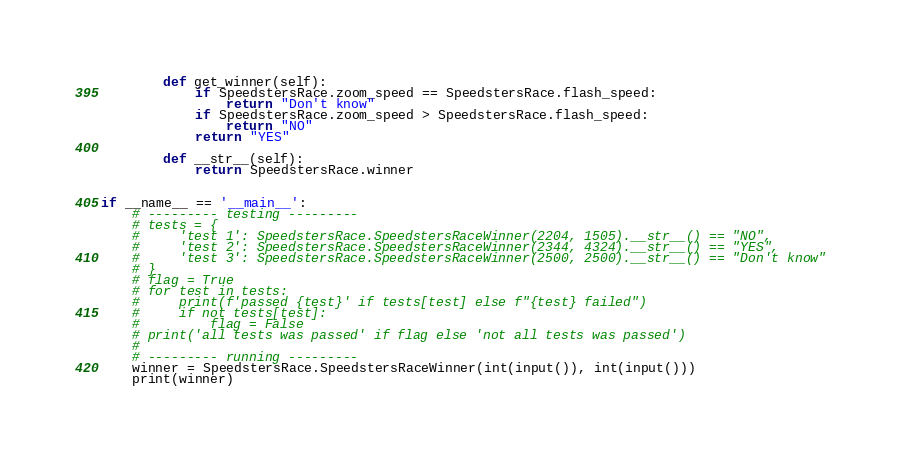Convert code to text. <code><loc_0><loc_0><loc_500><loc_500><_Python_>
        def get_winner(self):
            if SpeedstersRace.zoom_speed == SpeedstersRace.flash_speed:
                return "Don't know"
            if SpeedstersRace.zoom_speed > SpeedstersRace.flash_speed:
                return "NO"
            return "YES"

        def __str__(self):
            return SpeedstersRace.winner


if __name__ == '__main__':
    # --------- testing ---------
    # tests = {
    #     'test 1': SpeedstersRace.SpeedstersRaceWinner(2204, 1505).__str__() == "NO",
    #     'test 2': SpeedstersRace.SpeedstersRaceWinner(2344, 4324).__str__() == "YES",
    #     'test 3': SpeedstersRace.SpeedstersRaceWinner(2500, 2500).__str__() == "Don't know"
    # }
    # flag = True
    # for test in tests:
    #     print(f'passed {test}' if tests[test] else f"{test} failed")
    #     if not tests[test]:
    #         flag = False
    # print('all tests was passed' if flag else 'not all tests was passed')
    #
    # --------- running ---------
    winner = SpeedstersRace.SpeedstersRaceWinner(int(input()), int(input()))
    print(winner)

</code> 